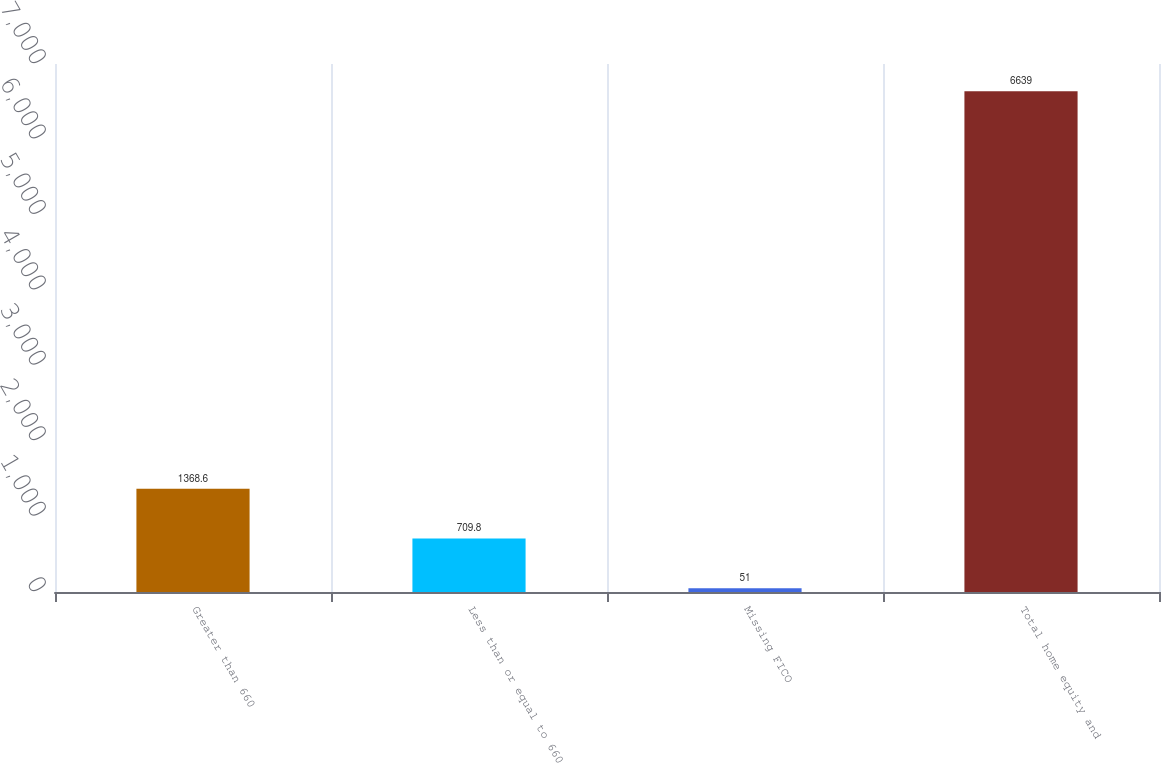Convert chart to OTSL. <chart><loc_0><loc_0><loc_500><loc_500><bar_chart><fcel>Greater than 660<fcel>Less than or equal to 660<fcel>Missing FICO<fcel>Total home equity and<nl><fcel>1368.6<fcel>709.8<fcel>51<fcel>6639<nl></chart> 